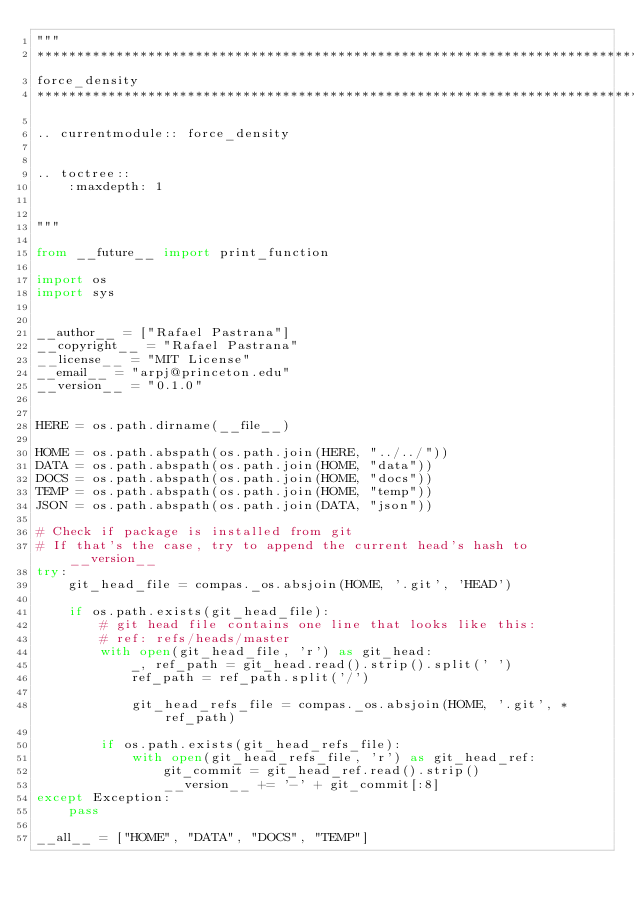<code> <loc_0><loc_0><loc_500><loc_500><_Python_>"""
********************************************************************************
force_density
********************************************************************************

.. currentmodule:: force_density


.. toctree::
    :maxdepth: 1


"""

from __future__ import print_function

import os
import sys


__author__ = ["Rafael Pastrana"]
__copyright__ = "Rafael Pastrana"
__license__ = "MIT License"
__email__ = "arpj@princeton.edu"
__version__ = "0.1.0"


HERE = os.path.dirname(__file__)

HOME = os.path.abspath(os.path.join(HERE, "../../"))
DATA = os.path.abspath(os.path.join(HOME, "data"))
DOCS = os.path.abspath(os.path.join(HOME, "docs"))
TEMP = os.path.abspath(os.path.join(HOME, "temp"))
JSON = os.path.abspath(os.path.join(DATA, "json"))

# Check if package is installed from git
# If that's the case, try to append the current head's hash to __version__
try:
    git_head_file = compas._os.absjoin(HOME, '.git', 'HEAD')

    if os.path.exists(git_head_file):
        # git head file contains one line that looks like this:
        # ref: refs/heads/master
        with open(git_head_file, 'r') as git_head:
            _, ref_path = git_head.read().strip().split(' ')
            ref_path = ref_path.split('/')

            git_head_refs_file = compas._os.absjoin(HOME, '.git', *ref_path)

        if os.path.exists(git_head_refs_file):
            with open(git_head_refs_file, 'r') as git_head_ref:
                git_commit = git_head_ref.read().strip()
                __version__ += '-' + git_commit[:8]
except Exception:
    pass

__all__ = ["HOME", "DATA", "DOCS", "TEMP"]
</code> 